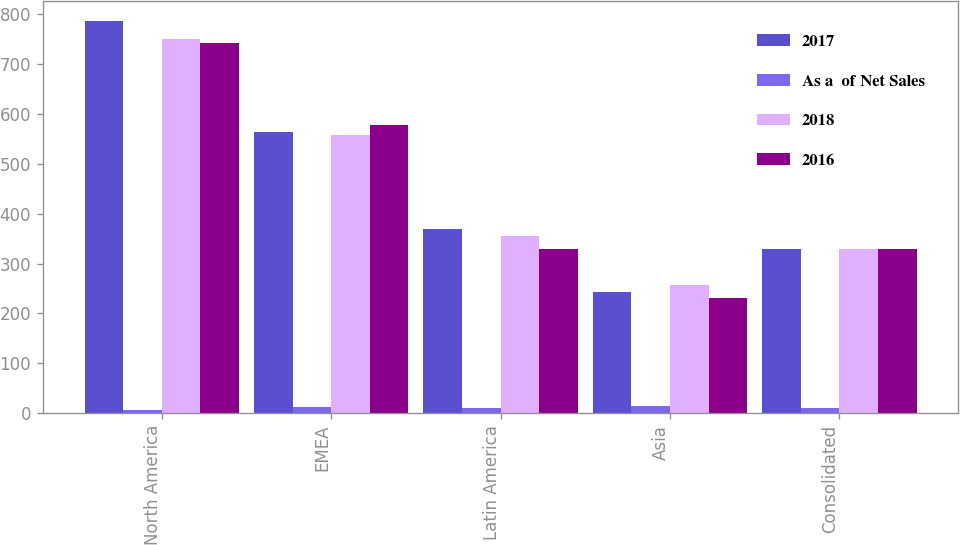Convert chart. <chart><loc_0><loc_0><loc_500><loc_500><stacked_bar_chart><ecel><fcel>North America<fcel>EMEA<fcel>Latin America<fcel>Asia<fcel>Consolidated<nl><fcel>2017<fcel>787<fcel>564<fcel>369<fcel>244<fcel>330<nl><fcel>As a  of Net Sales<fcel>6.9<fcel>12.4<fcel>10.2<fcel>15.4<fcel>10.4<nl><fcel>2018<fcel>751<fcel>557<fcel>356<fcel>258<fcel>330<nl><fcel>2016<fcel>742<fcel>577<fcel>330<fcel>231<fcel>330<nl></chart> 